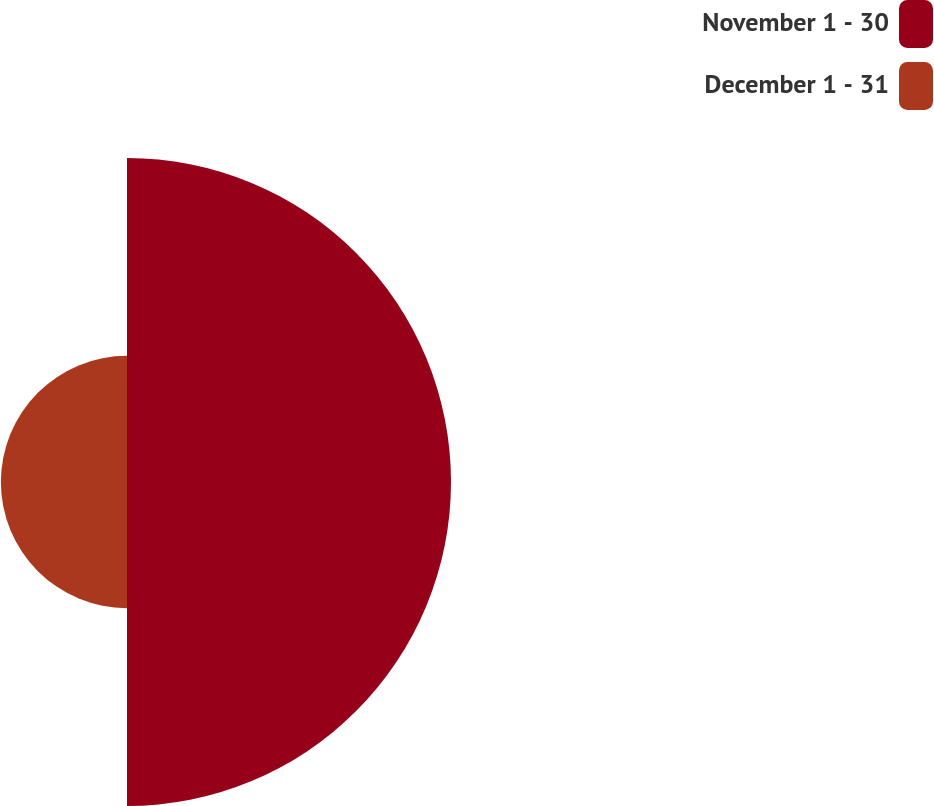Convert chart to OTSL. <chart><loc_0><loc_0><loc_500><loc_500><pie_chart><fcel>November 1 - 30<fcel>December 1 - 31<nl><fcel>71.98%<fcel>28.02%<nl></chart> 